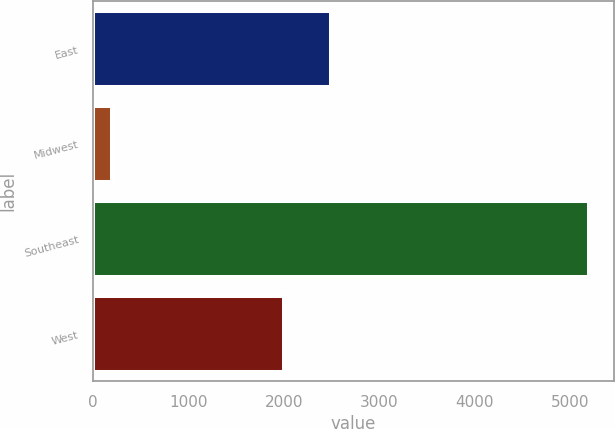Convert chart to OTSL. <chart><loc_0><loc_0><loc_500><loc_500><bar_chart><fcel>East<fcel>Midwest<fcel>Southeast<fcel>West<nl><fcel>2500<fcel>200<fcel>5200<fcel>2000<nl></chart> 